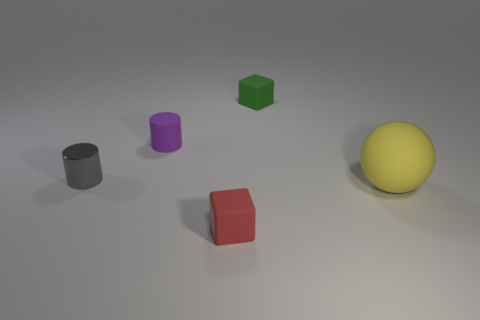Is there any other thing that has the same material as the tiny gray cylinder?
Offer a terse response. No. Are there any other objects that have the same shape as the green matte object?
Your answer should be very brief. Yes. There is a metallic object that is the same size as the green rubber cube; what is its shape?
Your response must be concise. Cylinder. How many tiny blocks are in front of the small thing that is on the left side of the small purple rubber cylinder?
Provide a succinct answer. 1. How big is the object that is in front of the gray metallic cylinder and right of the small red rubber thing?
Ensure brevity in your answer.  Large. Are there any shiny cylinders of the same size as the green matte object?
Your response must be concise. Yes. Are there more spheres that are right of the purple rubber object than small gray metal cylinders that are on the left side of the gray shiny object?
Your answer should be compact. Yes. Is the red object made of the same material as the small cylinder in front of the small matte cylinder?
Your response must be concise. No. What number of matte cylinders are on the right side of the small block that is on the right side of the tiny rubber block that is in front of the gray metallic cylinder?
Offer a very short reply. 0. There is a tiny red matte thing; does it have the same shape as the thing that is to the left of the purple cylinder?
Offer a very short reply. No. 